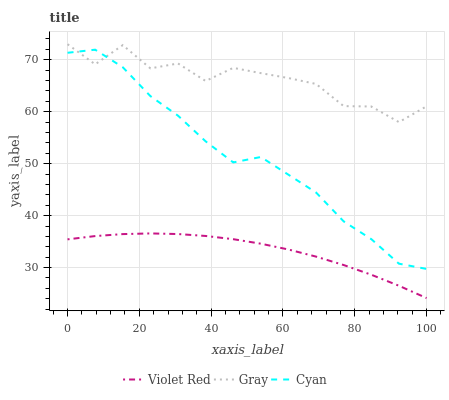Does Violet Red have the minimum area under the curve?
Answer yes or no. Yes. Does Gray have the maximum area under the curve?
Answer yes or no. Yes. Does Cyan have the minimum area under the curve?
Answer yes or no. No. Does Cyan have the maximum area under the curve?
Answer yes or no. No. Is Violet Red the smoothest?
Answer yes or no. Yes. Is Gray the roughest?
Answer yes or no. Yes. Is Cyan the smoothest?
Answer yes or no. No. Is Cyan the roughest?
Answer yes or no. No. Does Violet Red have the lowest value?
Answer yes or no. Yes. Does Cyan have the lowest value?
Answer yes or no. No. Does Gray have the highest value?
Answer yes or no. Yes. Does Cyan have the highest value?
Answer yes or no. No. Is Violet Red less than Gray?
Answer yes or no. Yes. Is Gray greater than Violet Red?
Answer yes or no. Yes. Does Cyan intersect Gray?
Answer yes or no. Yes. Is Cyan less than Gray?
Answer yes or no. No. Is Cyan greater than Gray?
Answer yes or no. No. Does Violet Red intersect Gray?
Answer yes or no. No. 